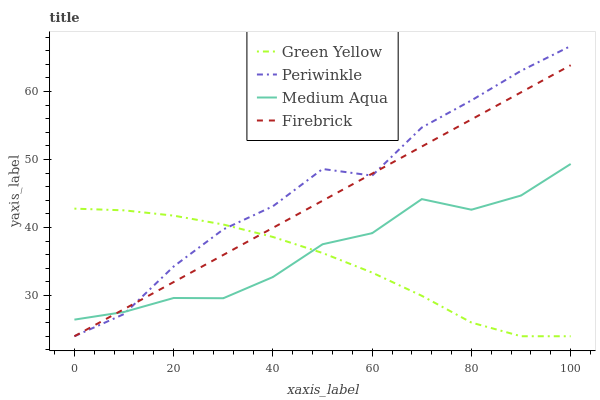Does Firebrick have the minimum area under the curve?
Answer yes or no. No. Does Firebrick have the maximum area under the curve?
Answer yes or no. No. Is Green Yellow the smoothest?
Answer yes or no. No. Is Green Yellow the roughest?
Answer yes or no. No. Does Firebrick have the highest value?
Answer yes or no. No. 